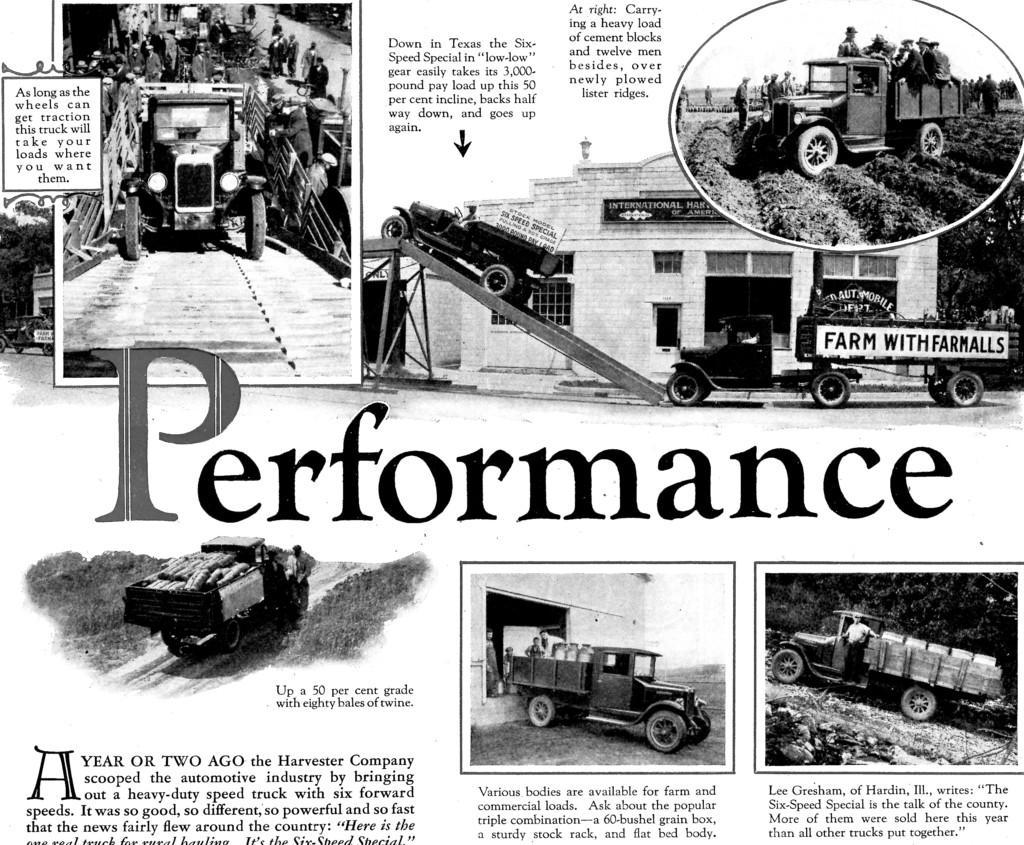How would you summarize this image in a sentence or two? In this image I can see the paper. In the paper I can see the vehicles, few people and the text. I can also see the name performance is written on it. And this is a black and white image. 